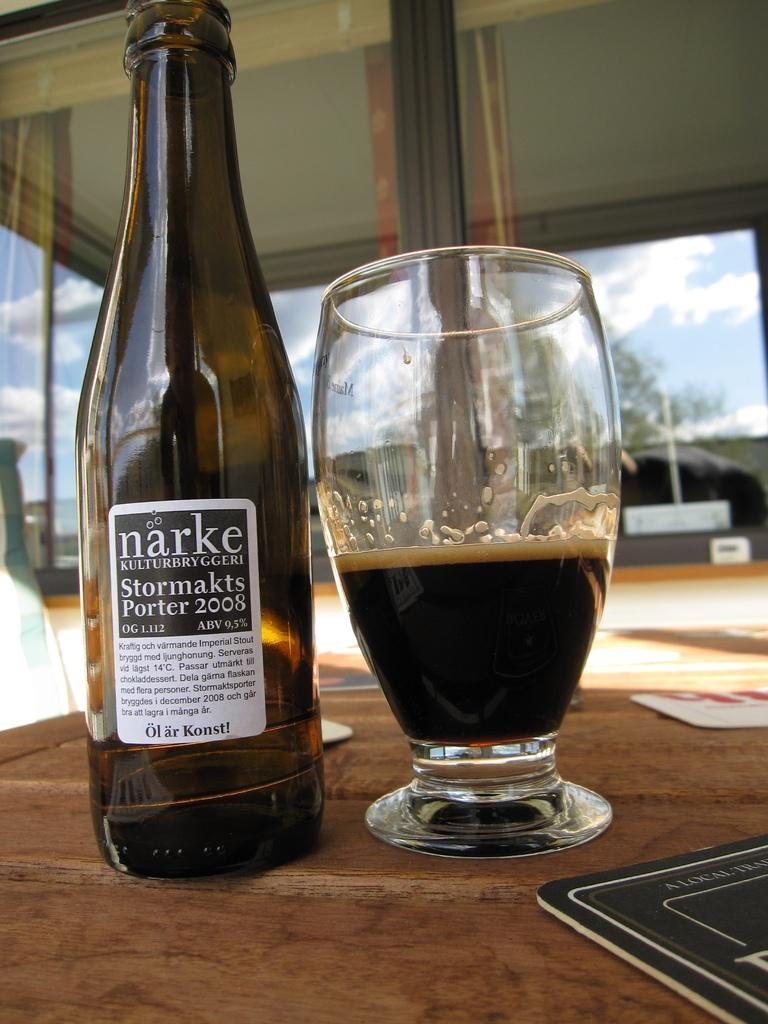<image>
Offer a succinct explanation of the picture presented. A bottle of Narke porter sits next to a glass on a table. 